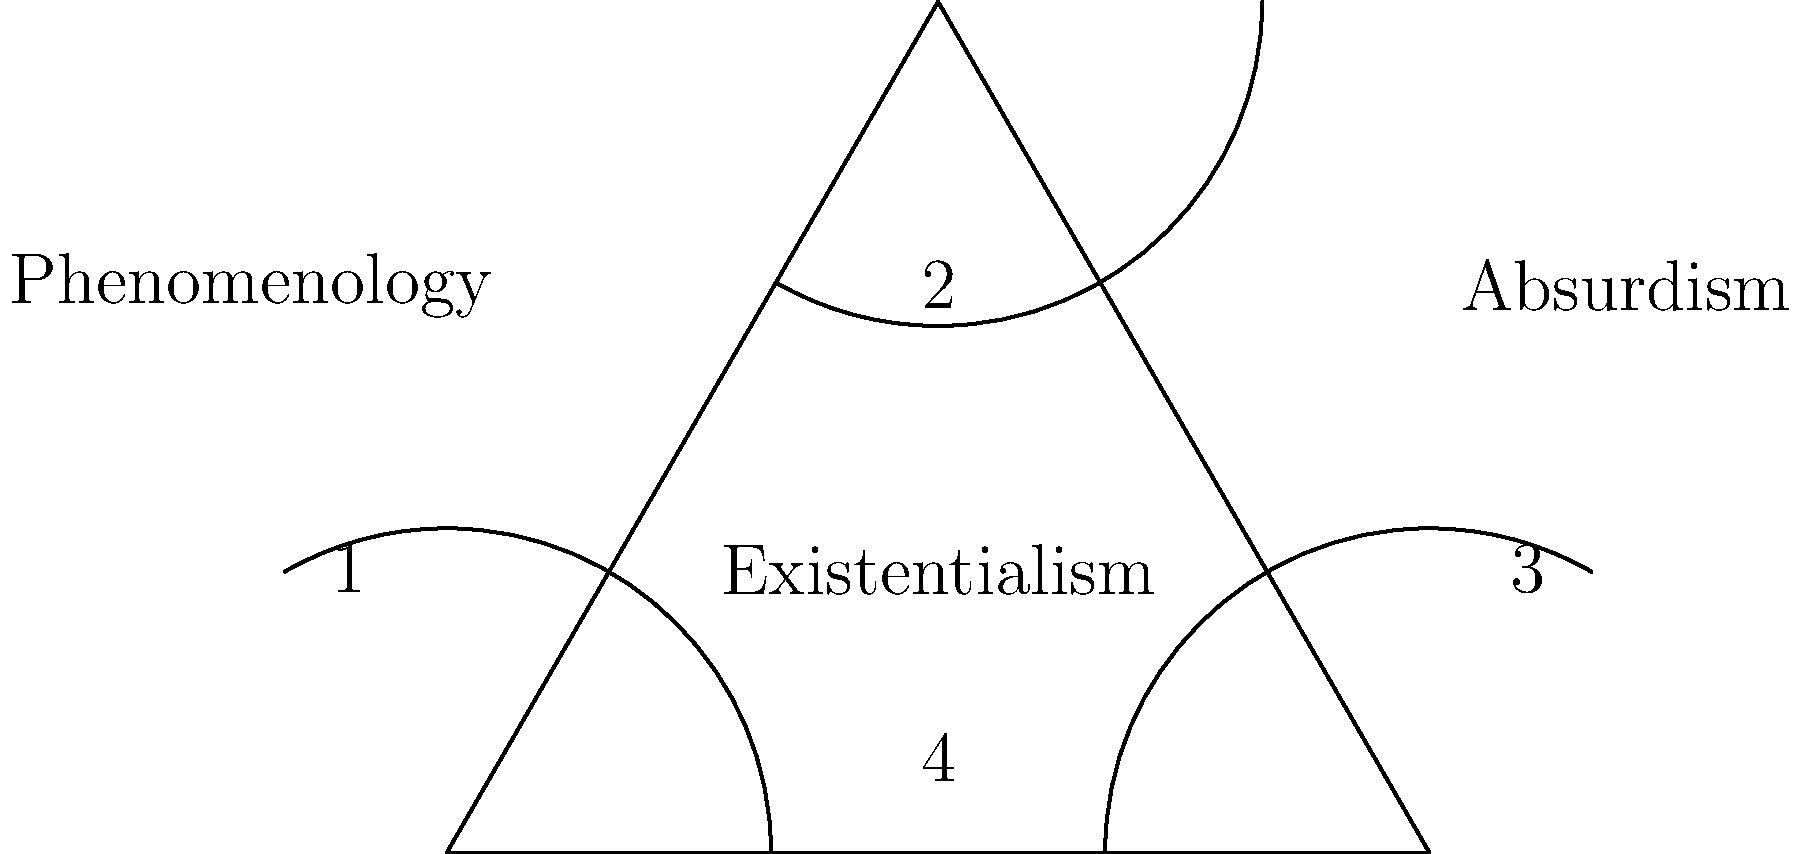In the Venn diagram comparing existentialism with phenomenology and absurdism, which region represents the unique aspects of existentialism that are not shared with the other two philosophical movements? To answer this question, we need to analyze the Venn diagram and understand the relationships between existentialism, phenomenology, and absurdism:

1. The diagram shows three overlapping circles, each representing one of the philosophical movements:
   - Existentialism (center)
   - Phenomenology (left)
   - Absurdism (right)

2. The overlapping regions represent shared characteristics between the movements:
   - Region 1: Shared by phenomenology and existentialism
   - Region 2: Shared by all three movements
   - Region 3: Shared by existentialism and absurdism

3. The non-overlapping regions represent unique aspects of each movement:
   - Region 4: Unique to existentialism
   - The unlabeled region on the far left: Unique to phenomenology
   - The unlabeled region on the far right: Unique to absurdism

4. The question asks for the region representing unique aspects of existentialism not shared with the other two movements.

5. This corresponds to region 4, which is within the existentialism circle but outside the overlaps with phenomenology and absurdism.

Therefore, the region that represents the unique aspects of existentialism is region 4.
Answer: 4 